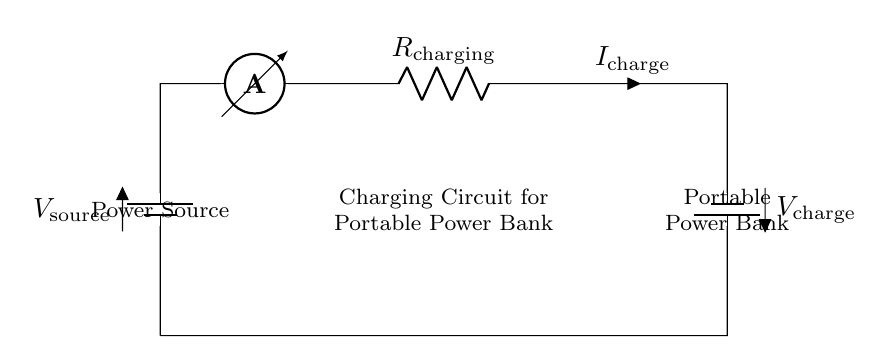What is the type of power source used in this circuit? The diagram shows a battery labeled as the power source, which indicates that it provides electrical energy for charging.
Answer: Battery What is the function of the resistor in this circuit? The resistor, labeled as R charging, is used to limit the current flowing to the portable power bank during the charging process to prevent damage.
Answer: Current limiting What is the direction of current flow in this circuit? The current flows from the power source through the ammeter and resistor toward the portable power bank, as indicated by the arrow labeled I charge.
Answer: From power source to power bank What is V charge in this circuit? The voltage across the portable power bank is labeled as V charge, representing the power bank's charging voltage. The exact value would depend on the specifications of the circuit components.
Answer: V charge How does the ammeter function in this series circuit? The ammeter measures the current in the circuit, providing an indication of how much current is flowing through the circuit for charging the power bank.
Answer: Current measurement What happens if the charging resistor is removed from the circuit? Without the resistor, there would be no limit to the current flowing into the power bank, which could lead to overheating and potential damage to the power bank.
Answer: Risk of damage What is the purpose of a portable power bank in this circuit? The portable power bank is designed to store the electrical energy provided by the power source, allowing users to charge electronic devices while sketching outdoors.
Answer: Energy storage 